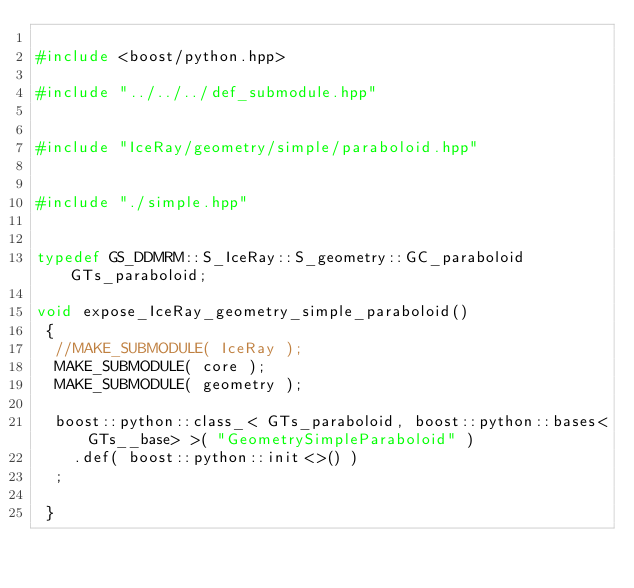Convert code to text. <code><loc_0><loc_0><loc_500><loc_500><_C++_>
#include <boost/python.hpp>

#include "../../../def_submodule.hpp"


#include "IceRay/geometry/simple/paraboloid.hpp"


#include "./simple.hpp"


typedef GS_DDMRM::S_IceRay::S_geometry::GC_paraboloid         GTs_paraboloid;

void expose_IceRay_geometry_simple_paraboloid()
 {
  //MAKE_SUBMODULE( IceRay );
  MAKE_SUBMODULE( core );
  MAKE_SUBMODULE( geometry );

  boost::python::class_< GTs_paraboloid, boost::python::bases<GTs__base> >( "GeometrySimpleParaboloid" )
    .def( boost::python::init<>() )
  ;

 }
</code> 